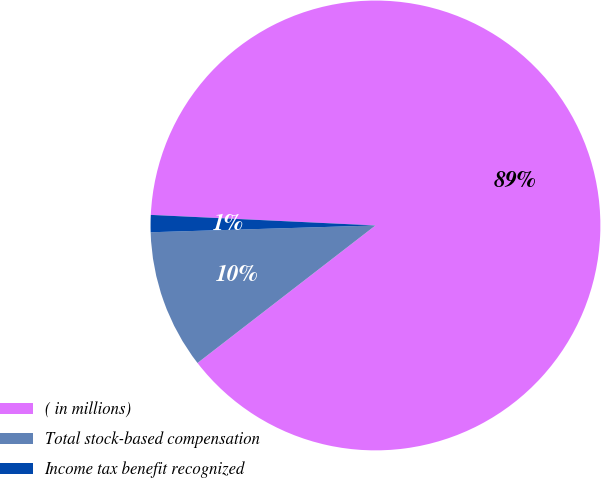Convert chart to OTSL. <chart><loc_0><loc_0><loc_500><loc_500><pie_chart><fcel>( in millions)<fcel>Total stock-based compensation<fcel>Income tax benefit recognized<nl><fcel>88.78%<fcel>9.99%<fcel>1.23%<nl></chart> 